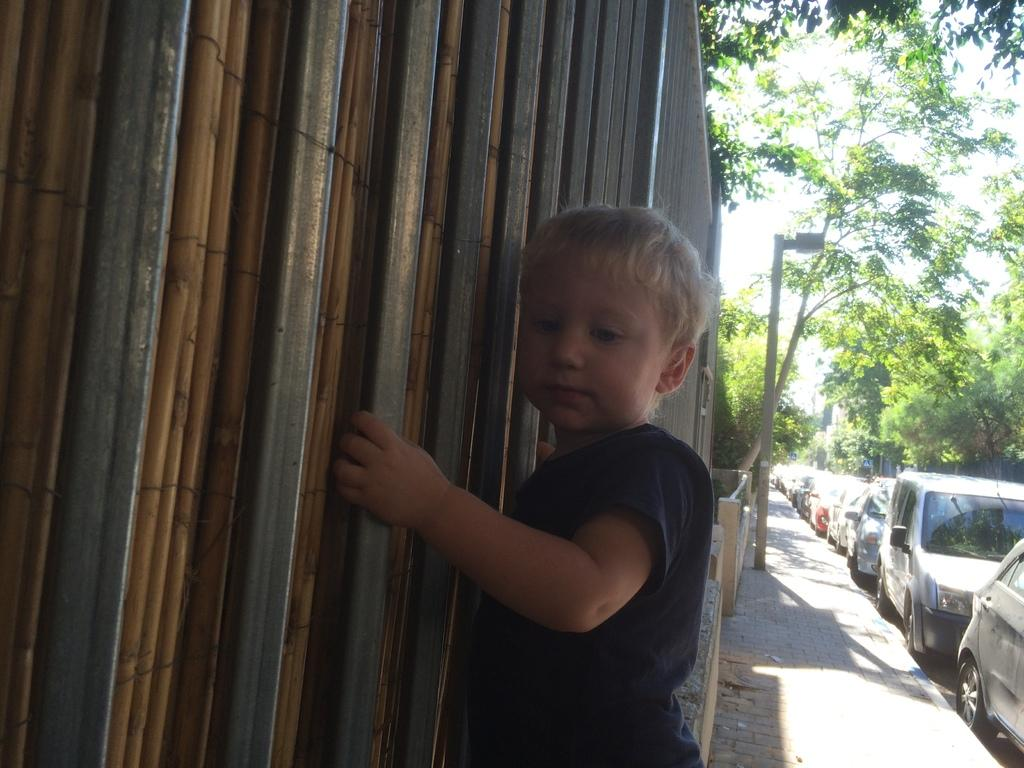Who is the main subject in the image? There is a boy in the image. What is located behind the boy? There is fencing behind the boy. What other objects can be seen in the image? There are poles visible in the image. What can be seen in the background of the image? There are trees and vehicles in the background of the image. Can you tell me how many babies are swimming in the image? There are no babies or swimming activities present in the image. 